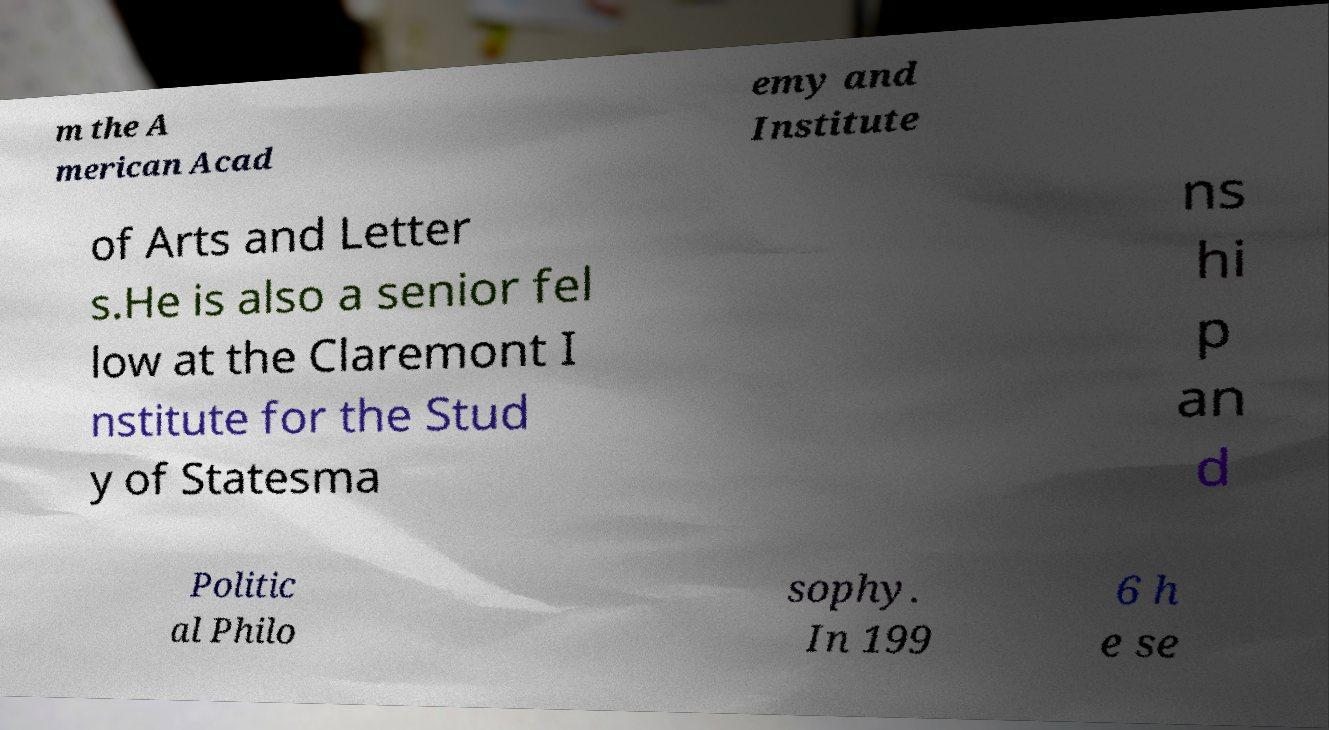Could you extract and type out the text from this image? m the A merican Acad emy and Institute of Arts and Letter s.He is also a senior fel low at the Claremont I nstitute for the Stud y of Statesma ns hi p an d Politic al Philo sophy. In 199 6 h e se 